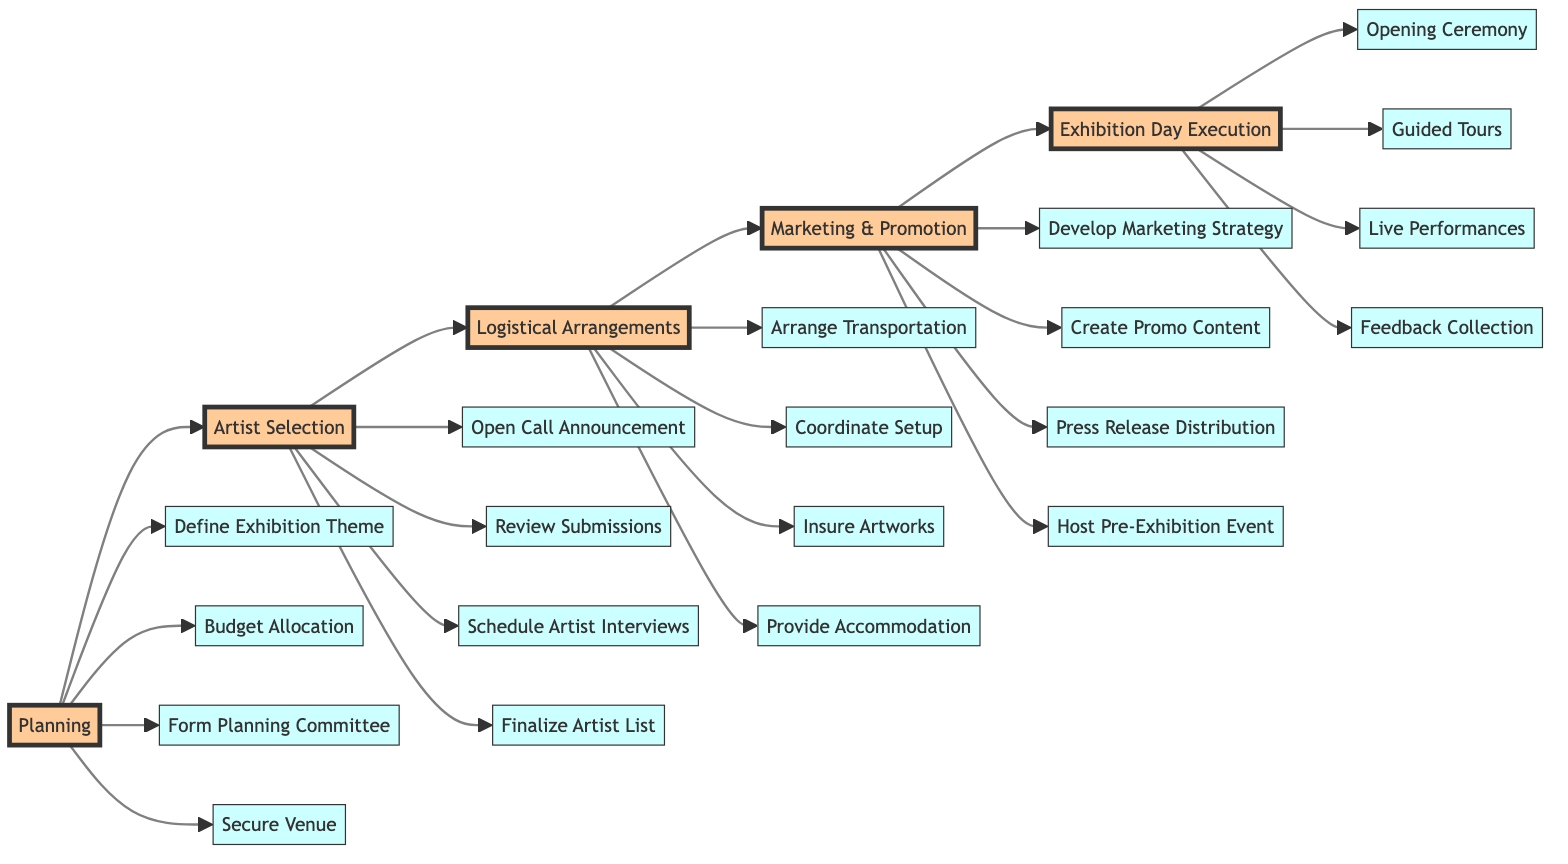What is the first step in the diagram? The first step in the flowchart under the "Planning" stage is "Define Exhibition Theme and Goals." This is the first node directly under the "Planning" stage, which indicates it is the initial action taken.
Answer: Define Exhibition Theme and Goals How many stages are there in total? The diagram includes five main stages which are "Planning," "Artist Selection," "Logistical Arrangements," "Marketing & Promotion," and "Exhibition Day Execution." Each stage serves as a major milestone in the process of curating the exhibition.
Answer: 5 What comes immediately after "Artist Selection"? The stage that follows "Artist Selection" is "Logistical Arrangements." The flow is directed from "Artist Selection" to "Logistical Arrangements" indicating this is the next step in the process.
Answer: Logistical Arrangements How many steps are included in the Marketing & Promotion stage? There are four specific steps listed in the "Marketing & Promotion" stage: 1) Develop Marketing Strategy, 2) Create Promo Content, 3) Press Release Distribution, and 4) Host Pre-Exhibition Event. This count is based on the individual items directly connected under that stage.
Answer: 4 What is the final activity listed under Exhibition Day Execution? The last activity in the "Exhibition Day Execution" stage is "Feedback Collection and Guestbook Signing." It is the final node directly under this stage indicating it is the concluding action on the exhibition day.
Answer: Feedback Collection and Guestbook Signing Which stage has the most steps? The "Artist Selection" stage has four steps: 1) Open Call Announcement, 2) Review Submissions, 3) Schedule Artist Interviews, and 4) Finalize Artist List. Each of these actions is critical for selecting the artists and ensuring a diverse representation.
Answer: Artist Selection What are the names of the two venues considered for securing? The two venues considered for securing are "Bozar" and "La Boverie." These venues are mentioned directly in the planning step where the venue selection is crucial for hosting the exhibition.
Answer: Bozar, La Boverie Which organization is responsible for budget allocations? The organization responsible for budget allocations is the "King Baudouin Foundation." This is stated as part of the planning stage, emphasizing the need for financial oversight and support from established institutions.
Answer: King Baudouin Foundation 